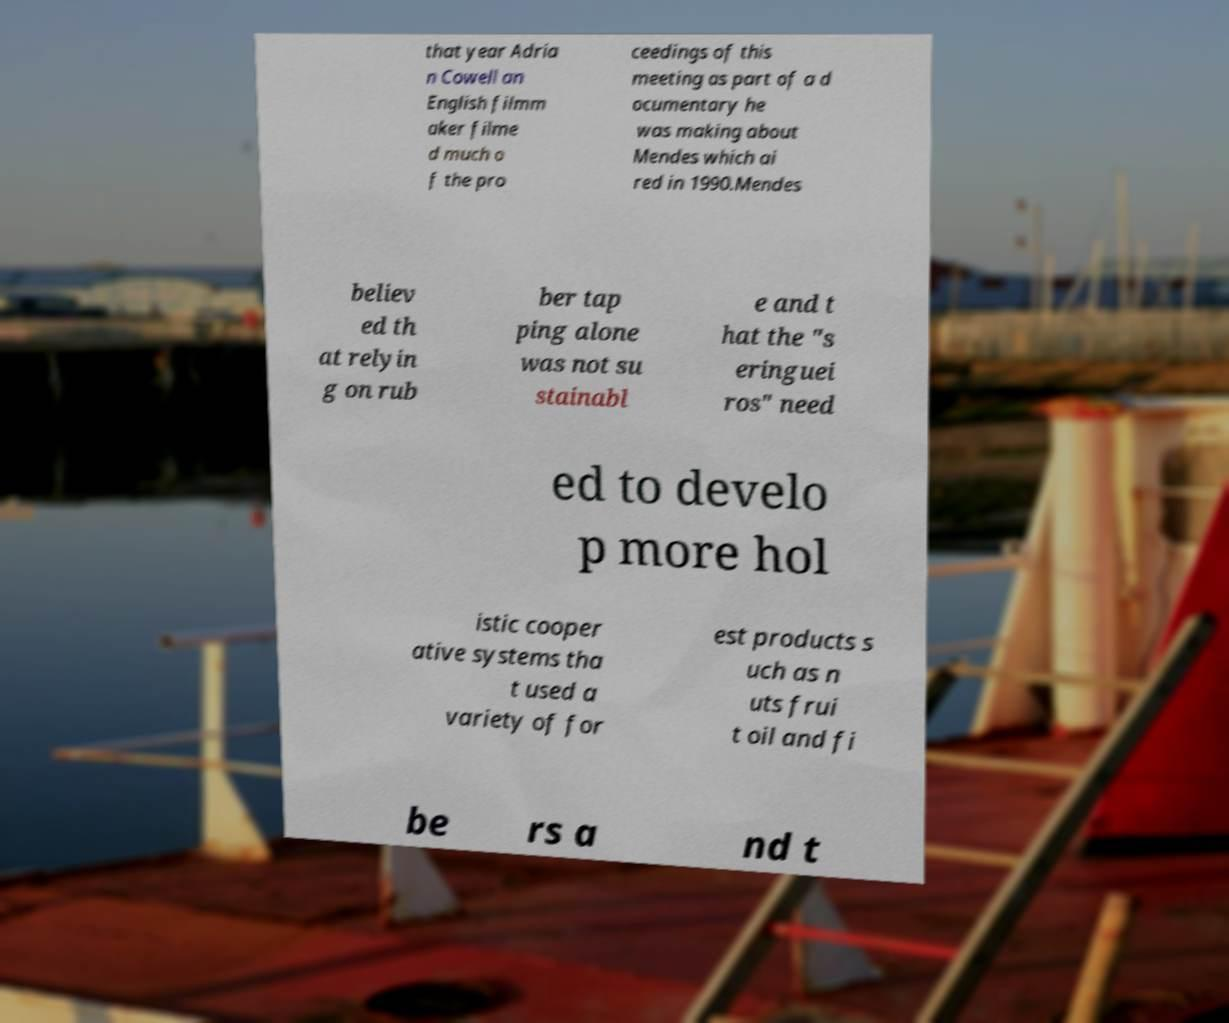Please identify and transcribe the text found in this image. that year Adria n Cowell an English filmm aker filme d much o f the pro ceedings of this meeting as part of a d ocumentary he was making about Mendes which ai red in 1990.Mendes believ ed th at relyin g on rub ber tap ping alone was not su stainabl e and t hat the "s eringuei ros" need ed to develo p more hol istic cooper ative systems tha t used a variety of for est products s uch as n uts frui t oil and fi be rs a nd t 